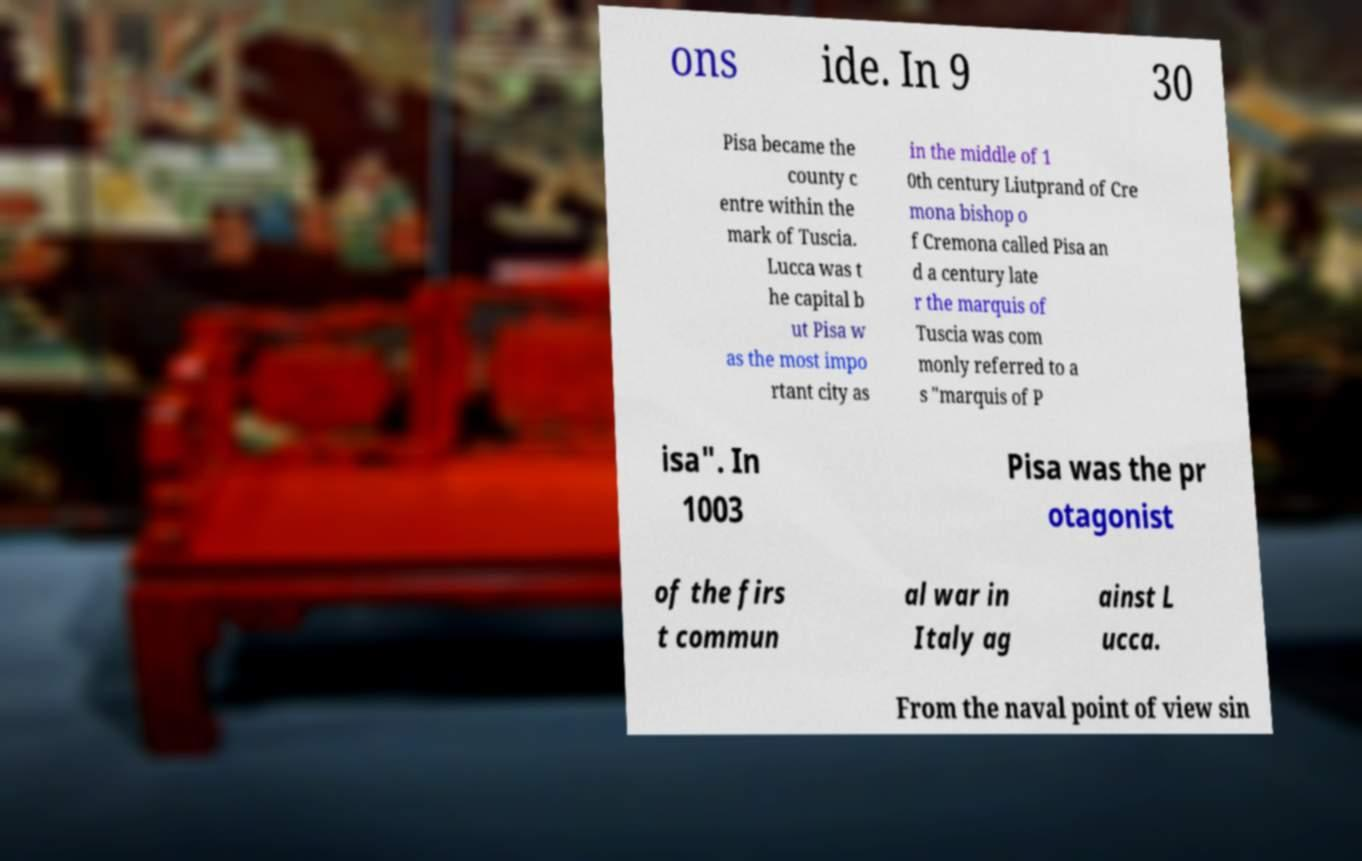For documentation purposes, I need the text within this image transcribed. Could you provide that? ons ide. In 9 30 Pisa became the county c entre within the mark of Tuscia. Lucca was t he capital b ut Pisa w as the most impo rtant city as in the middle of 1 0th century Liutprand of Cre mona bishop o f Cremona called Pisa an d a century late r the marquis of Tuscia was com monly referred to a s "marquis of P isa". In 1003 Pisa was the pr otagonist of the firs t commun al war in Italy ag ainst L ucca. From the naval point of view sin 